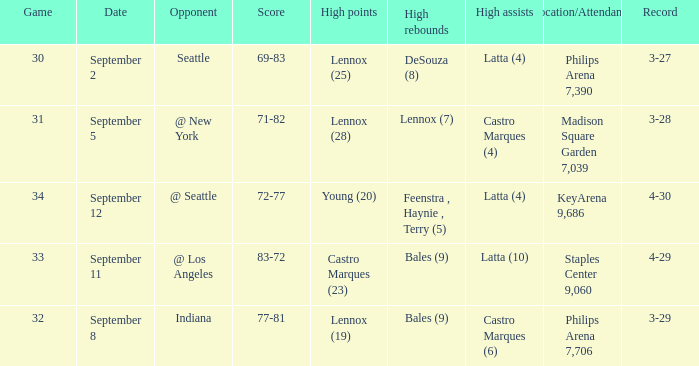What were the high rebounds on september 11? Bales (9). 